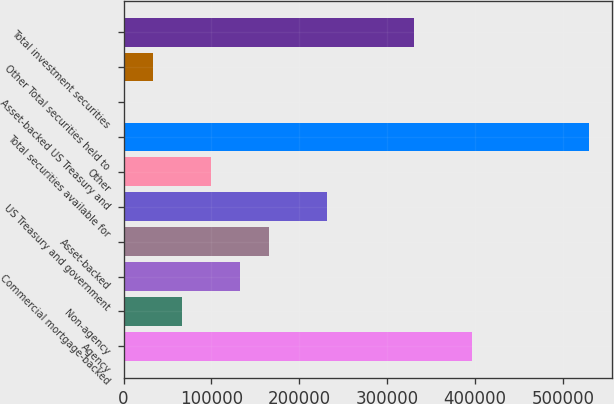Convert chart. <chart><loc_0><loc_0><loc_500><loc_500><bar_chart><fcel>Agency<fcel>Non-agency<fcel>Commercial mortgage-backed<fcel>Asset-backed<fcel>US Treasury and government<fcel>Other<fcel>Total securities available for<fcel>Asset-backed US Treasury and<fcel>Other Total securities held to<fcel>Total investment securities<nl><fcel>396871<fcel>66305.2<fcel>132418<fcel>165475<fcel>231588<fcel>99361.8<fcel>529098<fcel>192<fcel>33248.6<fcel>330758<nl></chart> 